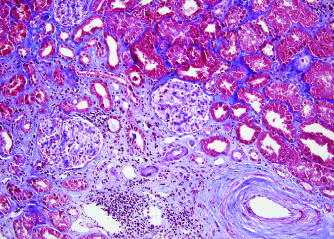does the tissue factor show fibrosis, contrasted with the normal kidney right in this trichrome stain?
Answer the question using a single word or phrase. No 